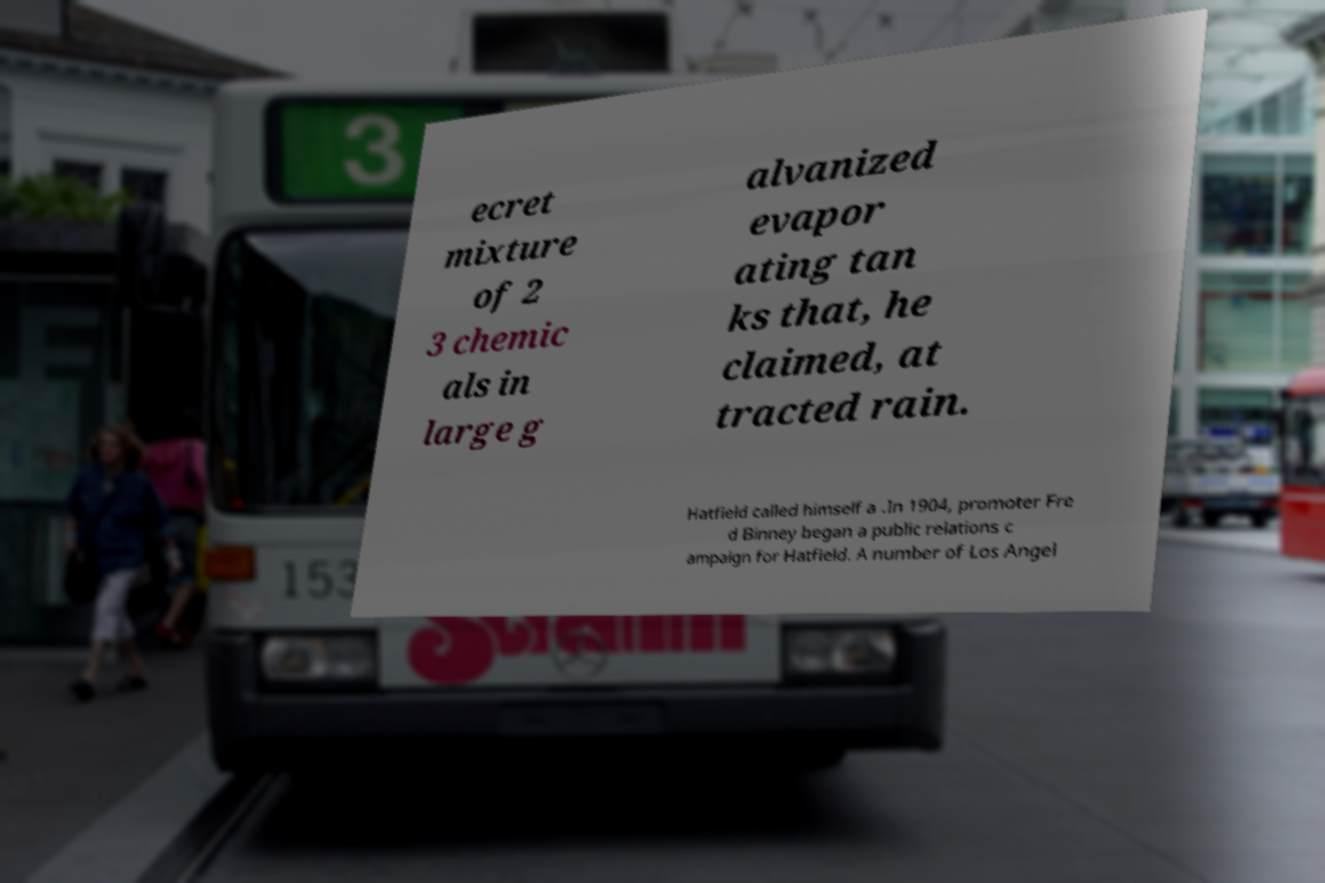Could you assist in decoding the text presented in this image and type it out clearly? ecret mixture of 2 3 chemic als in large g alvanized evapor ating tan ks that, he claimed, at tracted rain. Hatfield called himself a .In 1904, promoter Fre d Binney began a public relations c ampaign for Hatfield. A number of Los Angel 